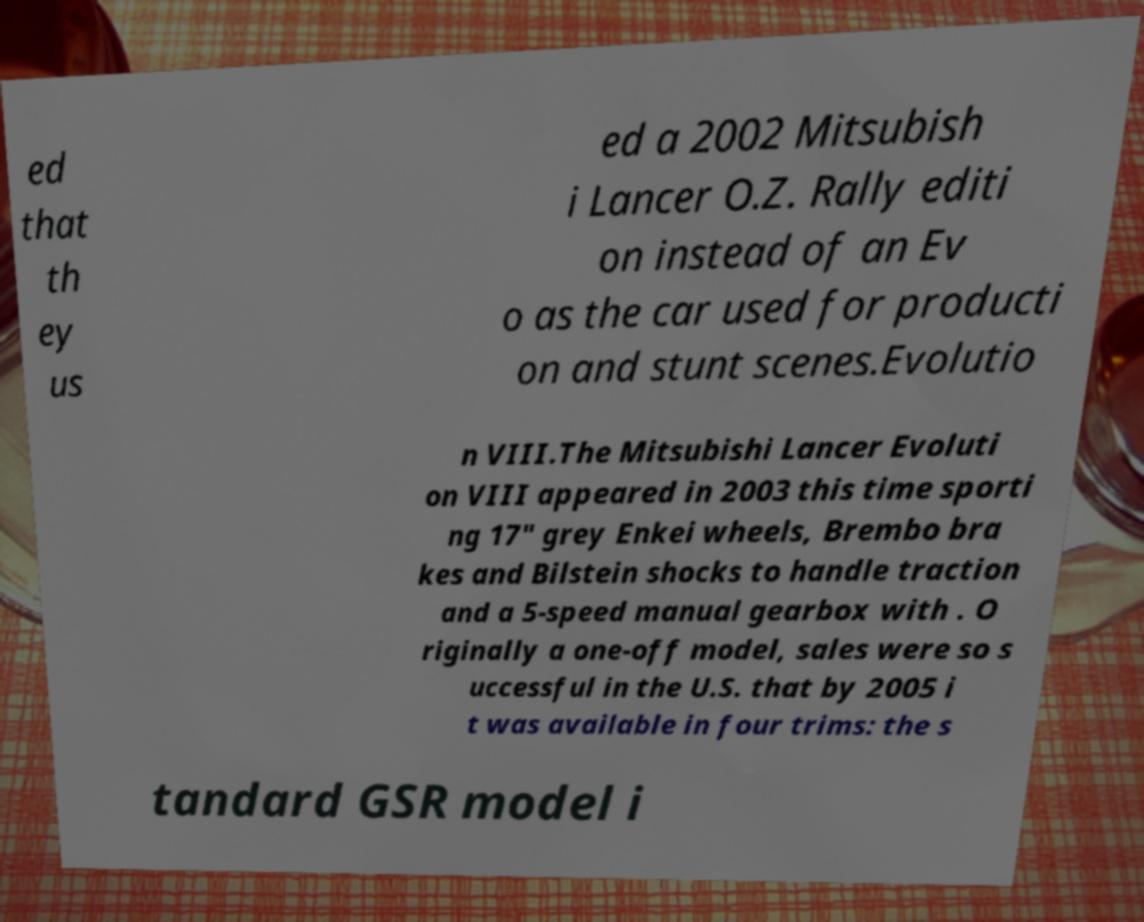Could you extract and type out the text from this image? ed that th ey us ed a 2002 Mitsubish i Lancer O.Z. Rally editi on instead of an Ev o as the car used for producti on and stunt scenes.Evolutio n VIII.The Mitsubishi Lancer Evoluti on VIII appeared in 2003 this time sporti ng 17" grey Enkei wheels, Brembo bra kes and Bilstein shocks to handle traction and a 5-speed manual gearbox with . O riginally a one-off model, sales were so s uccessful in the U.S. that by 2005 i t was available in four trims: the s tandard GSR model i 